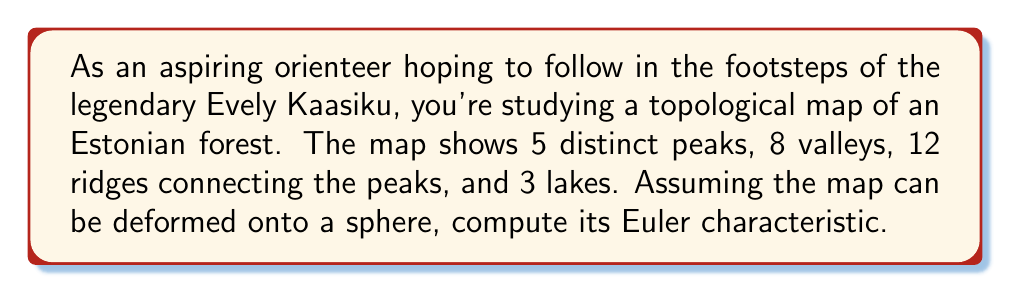Solve this math problem. To solve this problem, we'll use the Euler characteristic formula for a surface:

$$\chi = V - E + F$$

Where:
$\chi$ is the Euler characteristic
$V$ is the number of vertices
$E$ is the number of edges
$F$ is the number of faces

Let's identify each component:

1. Vertices (V): The peaks and valleys are our vertices.
   $V = 5 \text{ (peaks)} + 8 \text{ (valleys)} = 13$

2. Edges (E): The ridges connecting the peaks are our edges.
   $E = 12 \text{ (ridges)}$

3. Faces (F): We need to count the regions bounded by the ridges, including the lakes.
   - The map can be deformed onto a sphere, so the outer region counts as a face.
   - We have 3 lakes, each counting as a face.
   - The remaining faces are the regions bounded by the ridges.
   
   To find the number of remaining faces, we can use Euler's formula for planar graphs:
   $$V - E + F = 2$$
   
   Substituting the known values:
   $$13 - 12 + F = 2$$
   $$F = 2 - 13 + 12 = 1$$

   So there is 1 additional face besides the lakes and outer region.
   
   Total faces: $F = 1 \text{ (outer region)} + 3 \text{ (lakes)} + 1 \text{ (additional)} = 5$

Now we can calculate the Euler characteristic:

$$\chi = V - E + F = 13 - 12 + 5 = 6$$
Answer: $\chi = 6$ 